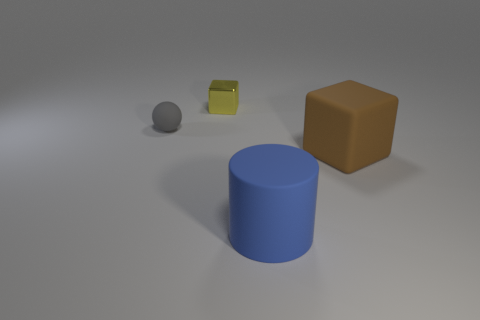Subtract all purple balls. Subtract all cyan blocks. How many balls are left? 1 Add 3 big red matte spheres. How many objects exist? 7 Subtract all balls. How many objects are left? 3 Subtract all big cylinders. Subtract all tiny green shiny cylinders. How many objects are left? 3 Add 4 rubber blocks. How many rubber blocks are left? 5 Add 1 small cyan rubber balls. How many small cyan rubber balls exist? 1 Subtract 0 red cylinders. How many objects are left? 4 